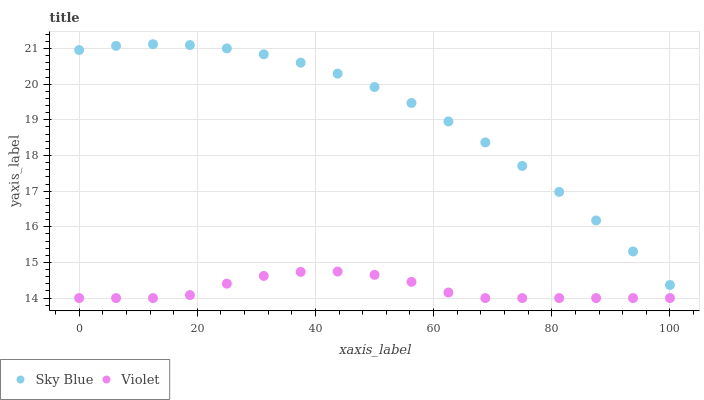Does Violet have the minimum area under the curve?
Answer yes or no. Yes. Does Sky Blue have the maximum area under the curve?
Answer yes or no. Yes. Does Violet have the maximum area under the curve?
Answer yes or no. No. Is Sky Blue the smoothest?
Answer yes or no. Yes. Is Violet the roughest?
Answer yes or no. Yes. Is Violet the smoothest?
Answer yes or no. No. Does Violet have the lowest value?
Answer yes or no. Yes. Does Sky Blue have the highest value?
Answer yes or no. Yes. Does Violet have the highest value?
Answer yes or no. No. Is Violet less than Sky Blue?
Answer yes or no. Yes. Is Sky Blue greater than Violet?
Answer yes or no. Yes. Does Violet intersect Sky Blue?
Answer yes or no. No. 